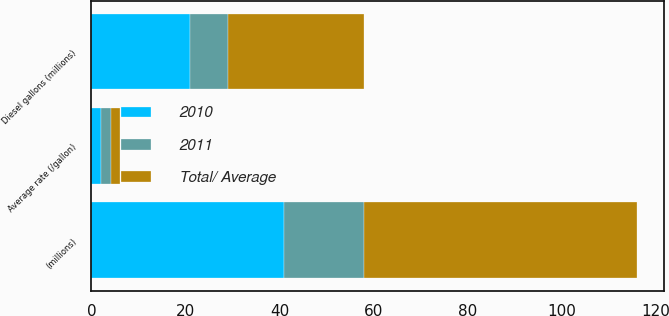<chart> <loc_0><loc_0><loc_500><loc_500><stacked_bar_chart><ecel><fcel>(millions)<fcel>Average rate (/gallon)<fcel>Diesel gallons (millions)<nl><fcel>2010<fcel>41<fcel>1.94<fcel>21<nl><fcel>2011<fcel>17<fcel>2.17<fcel>8<nl><fcel>Total/ Average<fcel>58<fcel>2<fcel>29<nl></chart> 